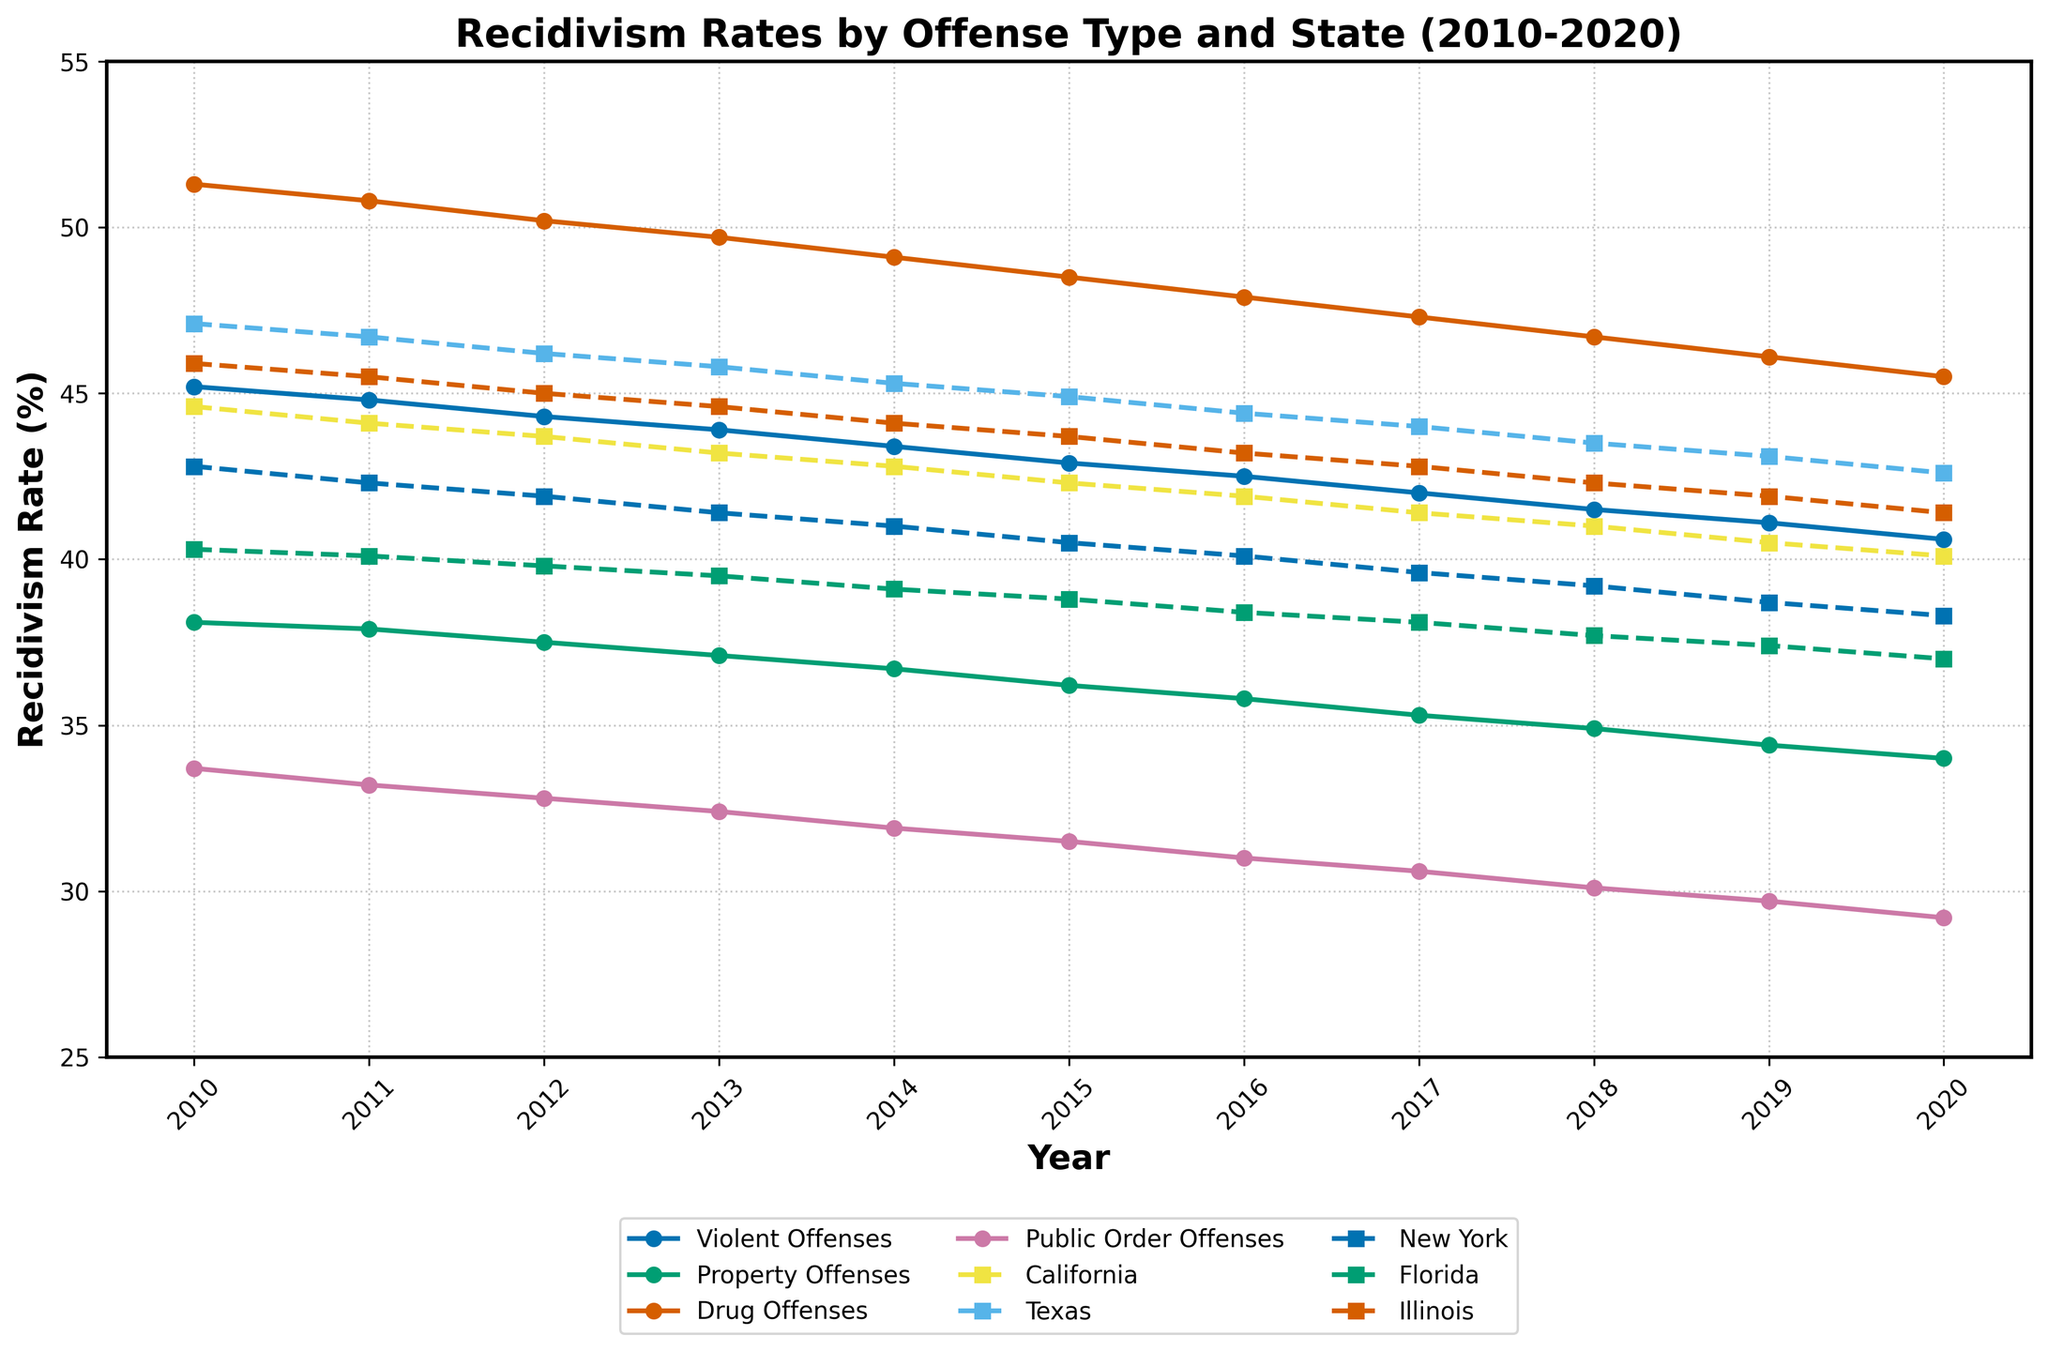Which offense type has the highest recidivism rate in 2010? Looking at the plot for the year 2010, compare the recidivism rates of all offense types. The offense type with the highest y-value corresponds to the highest rate.
Answer: Drug Offenses Which state had the lowest recidivism rate in 2015? For the year 2015, compare the recidivism rates across all states. The state with the lowest y-value has the lowest recidivism rate.
Answer: New York What is the difference in the recidivism rates of Drug Offenses between 2010 and 2020? Calculate the difference by subtracting the recidivism rate of Drug Offenses in 2020 from its value in 2010 (51.3 - 45.5).
Answer: 5.8 How does the trend of recidivism rates for Property Offenses compare to Violent Offenses from 2010 to 2020? Examine the lines of Property Offenses and Violent Offenses throughout the years. Observe the overall direction and changes in slopes to compare the trends. Both lines generally trend downward, but Property Offenses start and remain lower than Violent Offenses.
Answer: Both decrease, Property lower than Violent Which year saw the steepest decline in recidivism rates for Public Order Offenses? Identify the years by looking at the slopes of the line representing Public Order Offenses. The steepest decline corresponds to the year with the largest negative slope.
Answer: 2015 What is the average recidivism rate of California from 2010 to 2020? Sum the recidivism rates for California across all years (44.6 + 44.1 + 43.7 + 43.2 + 42.8 + 42.3 + 41.9 + 41.4 + 41.0 + 40.5 + 40.1) and then divide by the number of years (11).
Answer: 42.23 In which year did Illinois' recidivism rate fall below 45% for the first time? Track the y-values of Illinois over the years and identify the year in which it first goes below 45%.
Answer: 2013 Is the trend in recidivism rates for Texas consistent throughout the decade? Evaluate the line for Texas from 2010 to 2020, noting any changes in direction. If the line generally decreases or increases without significant fluctuation, it is consistent. Texas shows a relatively steady decline over the period.
Answer: Yes What visual clue differentiates state trends from offense types on the chart? Observe the line styles and markers used. Offense types are represented with solid lines and circular markers, while state lines use dashed lines and square markers.
Answer: Line style and markers 